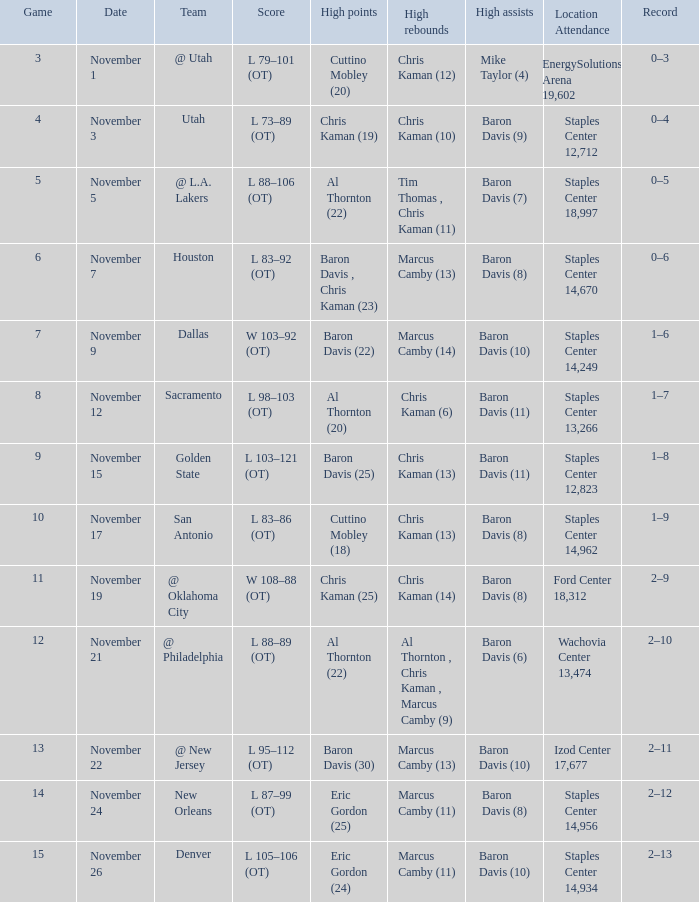Name the high assists for  l 98–103 (ot) Baron Davis (11). Would you be able to parse every entry in this table? {'header': ['Game', 'Date', 'Team', 'Score', 'High points', 'High rebounds', 'High assists', 'Location Attendance', 'Record'], 'rows': [['3', 'November 1', '@ Utah', 'L 79–101 (OT)', 'Cuttino Mobley (20)', 'Chris Kaman (12)', 'Mike Taylor (4)', 'EnergySolutions Arena 19,602', '0–3'], ['4', 'November 3', 'Utah', 'L 73–89 (OT)', 'Chris Kaman (19)', 'Chris Kaman (10)', 'Baron Davis (9)', 'Staples Center 12,712', '0–4'], ['5', 'November 5', '@ L.A. Lakers', 'L 88–106 (OT)', 'Al Thornton (22)', 'Tim Thomas , Chris Kaman (11)', 'Baron Davis (7)', 'Staples Center 18,997', '0–5'], ['6', 'November 7', 'Houston', 'L 83–92 (OT)', 'Baron Davis , Chris Kaman (23)', 'Marcus Camby (13)', 'Baron Davis (8)', 'Staples Center 14,670', '0–6'], ['7', 'November 9', 'Dallas', 'W 103–92 (OT)', 'Baron Davis (22)', 'Marcus Camby (14)', 'Baron Davis (10)', 'Staples Center 14,249', '1–6'], ['8', 'November 12', 'Sacramento', 'L 98–103 (OT)', 'Al Thornton (20)', 'Chris Kaman (6)', 'Baron Davis (11)', 'Staples Center 13,266', '1–7'], ['9', 'November 15', 'Golden State', 'L 103–121 (OT)', 'Baron Davis (25)', 'Chris Kaman (13)', 'Baron Davis (11)', 'Staples Center 12,823', '1–8'], ['10', 'November 17', 'San Antonio', 'L 83–86 (OT)', 'Cuttino Mobley (18)', 'Chris Kaman (13)', 'Baron Davis (8)', 'Staples Center 14,962', '1–9'], ['11', 'November 19', '@ Oklahoma City', 'W 108–88 (OT)', 'Chris Kaman (25)', 'Chris Kaman (14)', 'Baron Davis (8)', 'Ford Center 18,312', '2–9'], ['12', 'November 21', '@ Philadelphia', 'L 88–89 (OT)', 'Al Thornton (22)', 'Al Thornton , Chris Kaman , Marcus Camby (9)', 'Baron Davis (6)', 'Wachovia Center 13,474', '2–10'], ['13', 'November 22', '@ New Jersey', 'L 95–112 (OT)', 'Baron Davis (30)', 'Marcus Camby (13)', 'Baron Davis (10)', 'Izod Center 17,677', '2–11'], ['14', 'November 24', 'New Orleans', 'L 87–99 (OT)', 'Eric Gordon (25)', 'Marcus Camby (11)', 'Baron Davis (8)', 'Staples Center 14,956', '2–12'], ['15', 'November 26', 'Denver', 'L 105–106 (OT)', 'Eric Gordon (24)', 'Marcus Camby (11)', 'Baron Davis (10)', 'Staples Center 14,934', '2–13']]} 